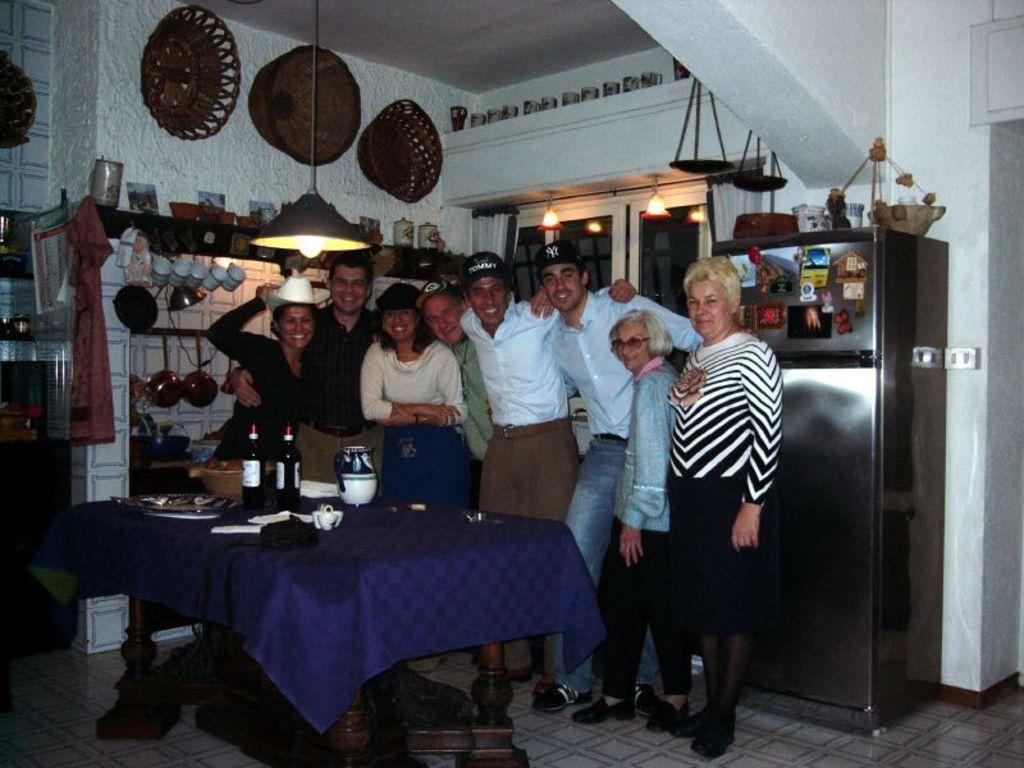Please provide a concise description of this image. In this picture there are many people standing in front of a table on which bottle, jars, plates were placed. There are women and men in this group. Light is hanging from the ceiling. In the background there are cups, baskets attached to the wall. We can observe a refrigerator here. 